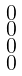Convert formula to latex. <formula><loc_0><loc_0><loc_500><loc_500>\begin{smallmatrix} 0 \\ 0 \\ 0 \\ 0 \end{smallmatrix}</formula> 